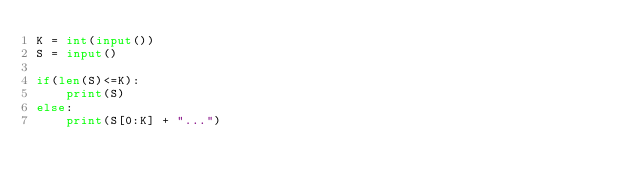Convert code to text. <code><loc_0><loc_0><loc_500><loc_500><_Python_>K = int(input())
S = input()

if(len(S)<=K):
    print(S)
else:
    print(S[0:K] + "...")
</code> 